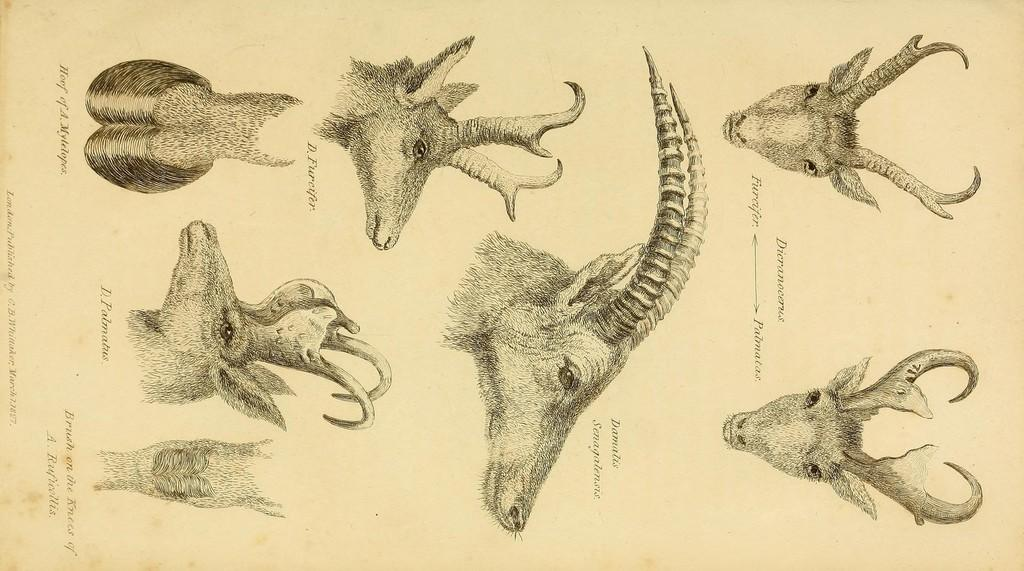What type of visual is the image? The image is a poster. What can be seen on the poster besides text? There are depictions of animals on the poster. What else is featured on the poster besides the images of animals? There is text on the poster. What color are the writer's eyes in the image? There is no writer present in the image, so it is not possible to determine the color of their eyes. 